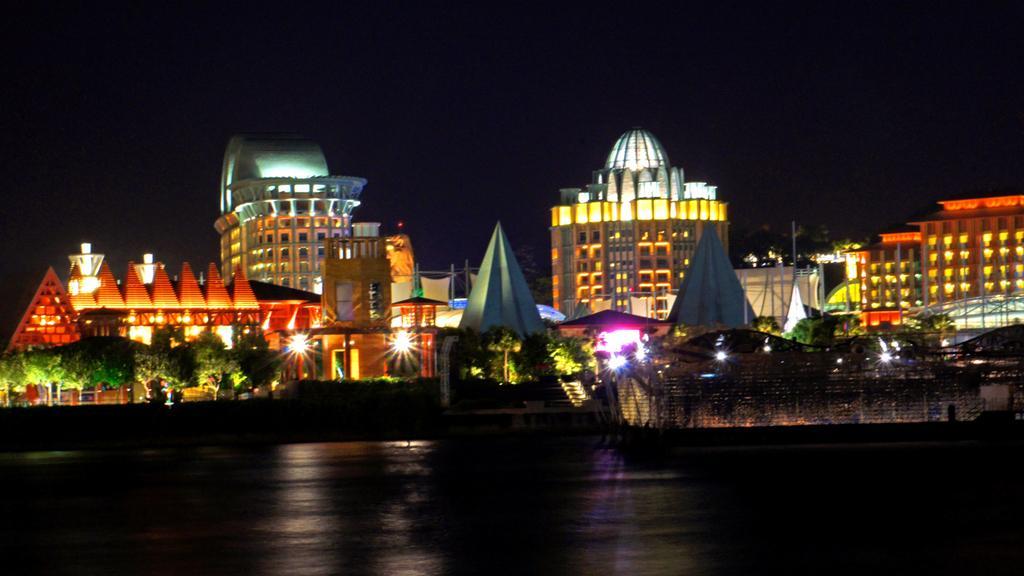In one or two sentences, can you explain what this image depicts? In this picture we can see the ground, here we can see buildings, trees, lights and some objects and in the background we can see it is dark. 